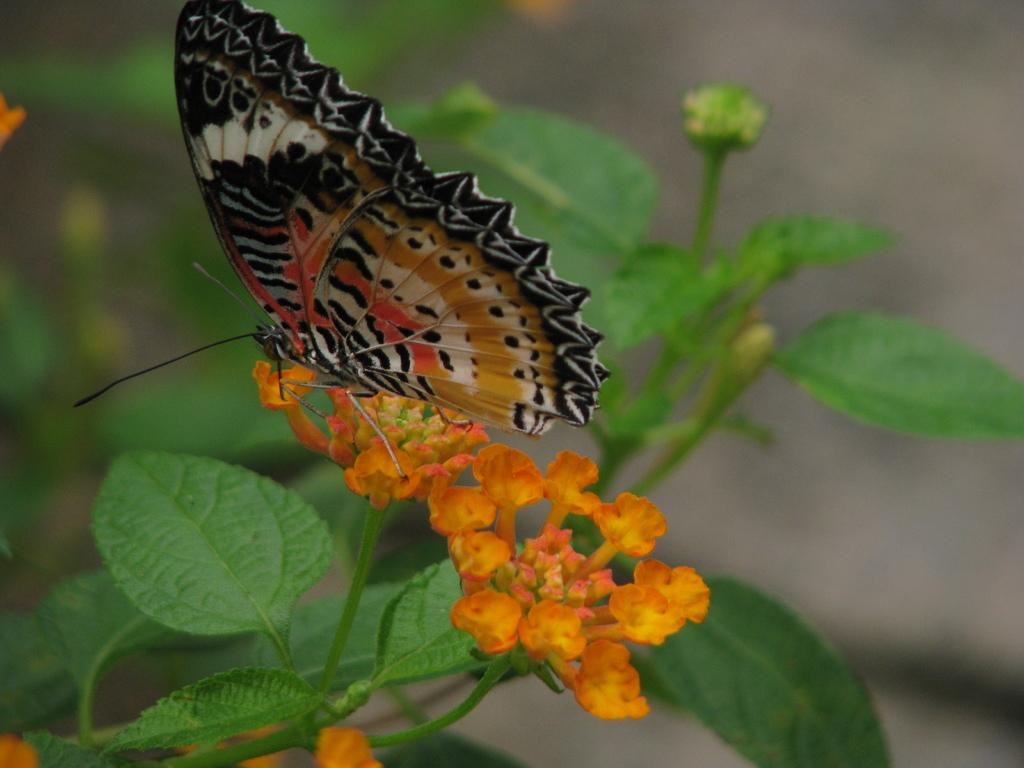What is the main subject of the image? There is a butterfly in the image. Where is the butterfly located? The butterfly is on flowers. What can be seen in the background of the image? There is a plant visible in the background of the image. Can you tell me how many fish are swimming in the ocean in the image? There is no ocean or fish present in the image; it features a butterfly on flowers with a plant in the background. 